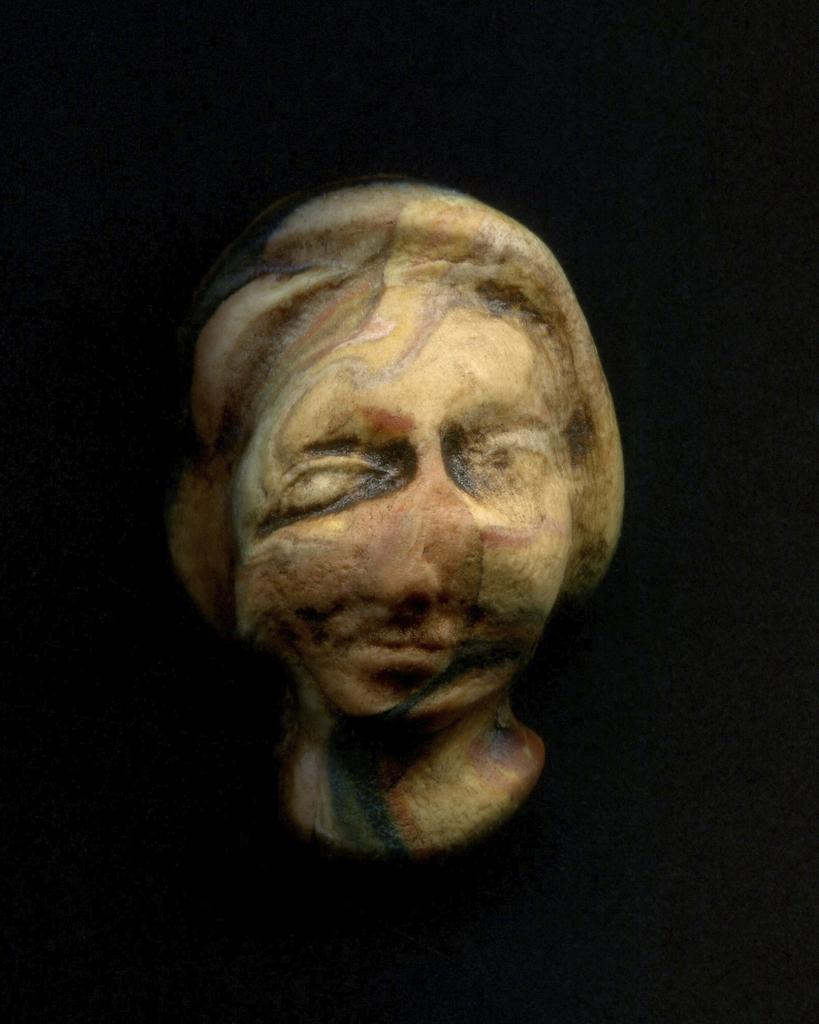What is the main subject of the image? There is a sculpture in the image. Where can the steam be seen coming from the sculpture in the image? There is no steam present in the image, as it only features a sculpture. 